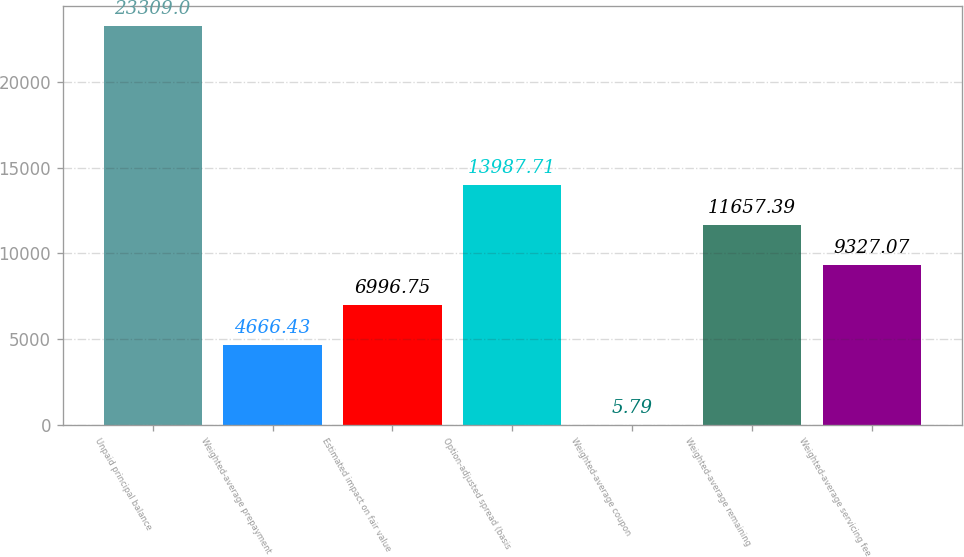Convert chart. <chart><loc_0><loc_0><loc_500><loc_500><bar_chart><fcel>Unpaid principal balance<fcel>Weighted-average prepayment<fcel>Estimated impact on fair value<fcel>Option-adjusted spread (basis<fcel>Weighted-average coupon<fcel>Weighted-average remaining<fcel>Weighted-average servicing fee<nl><fcel>23309<fcel>4666.43<fcel>6996.75<fcel>13987.7<fcel>5.79<fcel>11657.4<fcel>9327.07<nl></chart> 